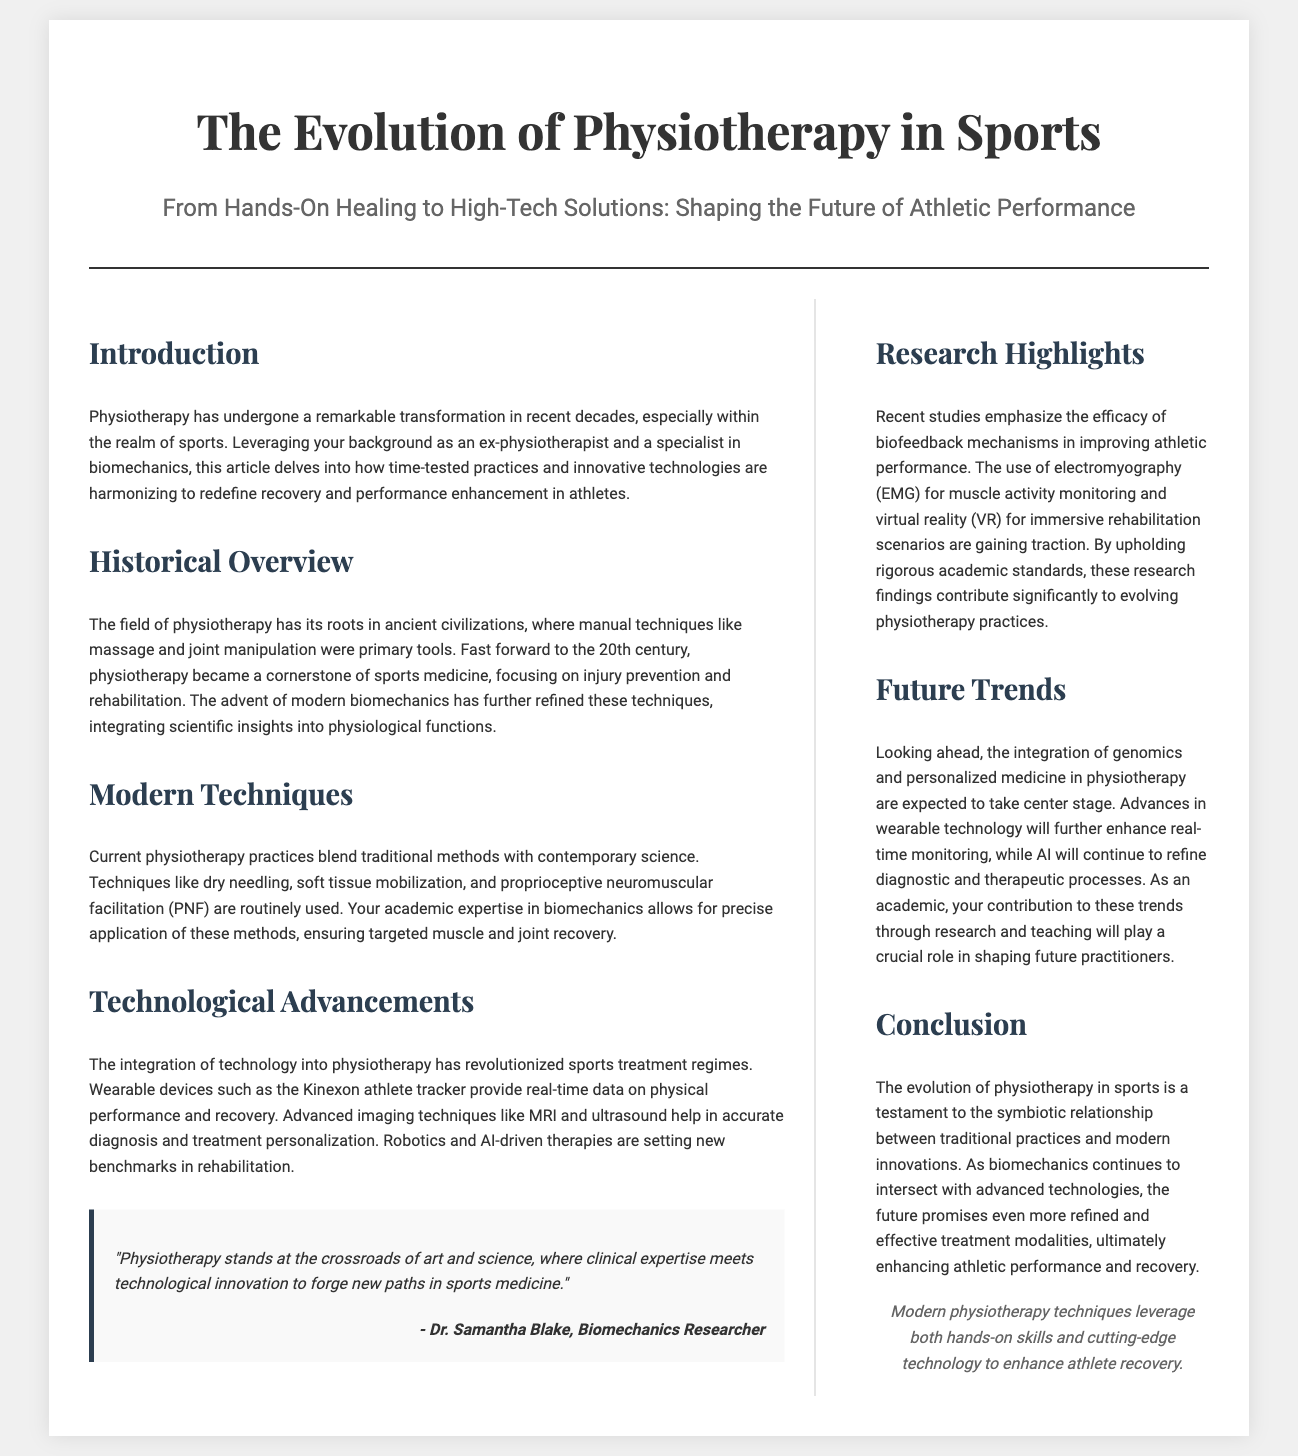What is the title of the article? The title is a primary piece of information found prominently in the header of the document.
Answer: The Evolution of Physiotherapy in Sports Who is the quote attributed to? The quote is mentioned in the quote section of the document, identifying its source.
Answer: Dr. Samantha Blake What does PNF stand for? The abbreviation is used in the context of describing modern techniques in the main content.
Answer: Proprioceptive Neuromuscular Facilitation What type of technology do Kinexon devices represent? The text describes the role of these devices in terms of athlete performance monitoring.
Answer: Wearable devices Which century saw physiotherapy become a cornerstone of sports medicine? The document specifies a historical milestone regarding the development of the field.
Answer: 20th century What is emphasized in the Research Highlights section? This section discusses research contributions to physiological practices in detail, aiming for depth of understanding.
Answer: Efficacy of biofeedback mechanisms What future trend involves the integration of genomics? The text mentions an anticipated focus for future practices as part of physiotherapy's evolution.
Answer: Personalized medicine How many columns are in the content layout? The layout structure provides a visual indication of the formatting used in the document.
Answer: Two columns 